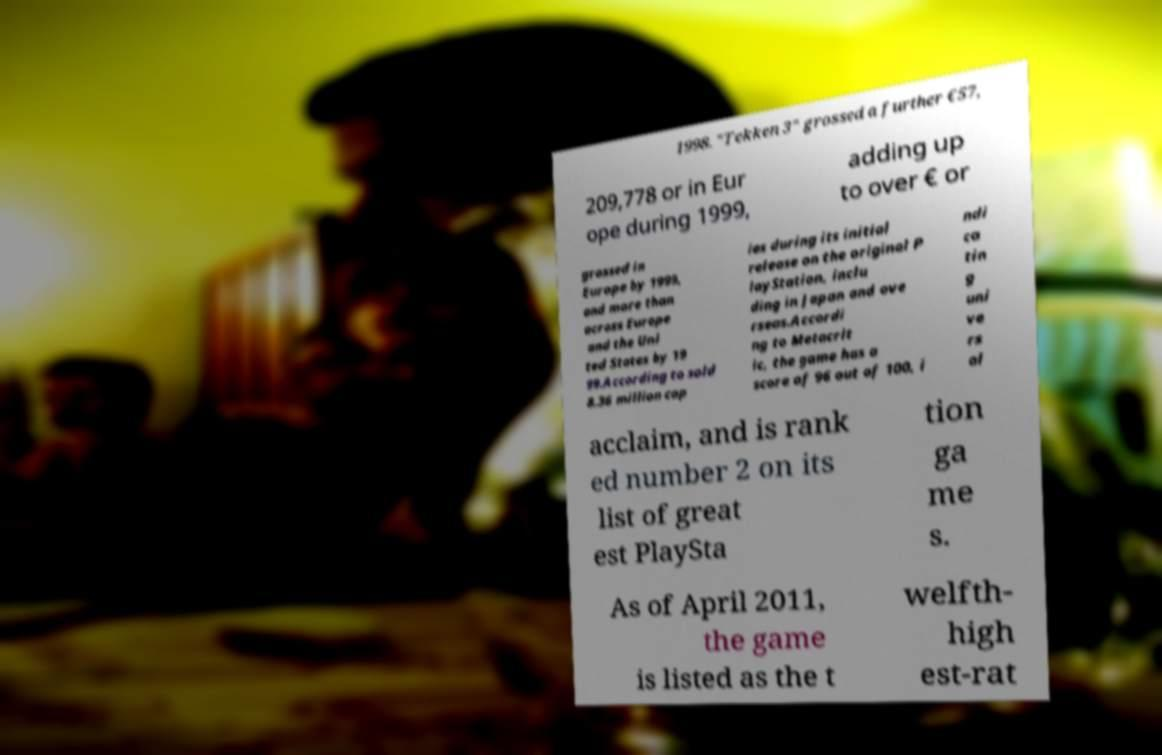Could you assist in decoding the text presented in this image and type it out clearly? 1998. "Tekken 3" grossed a further €57, 209,778 or in Eur ope during 1999, adding up to over € or grossed in Europe by 1999, and more than across Europe and the Uni ted States by 19 99.According to sold 8.36 million cop ies during its initial release on the original P layStation, inclu ding in Japan and ove rseas.Accordi ng to Metacrit ic, the game has a score of 96 out of 100, i ndi ca tin g uni ve rs al acclaim, and is rank ed number 2 on its list of great est PlaySta tion ga me s. As of April 2011, the game is listed as the t welfth- high est-rat 